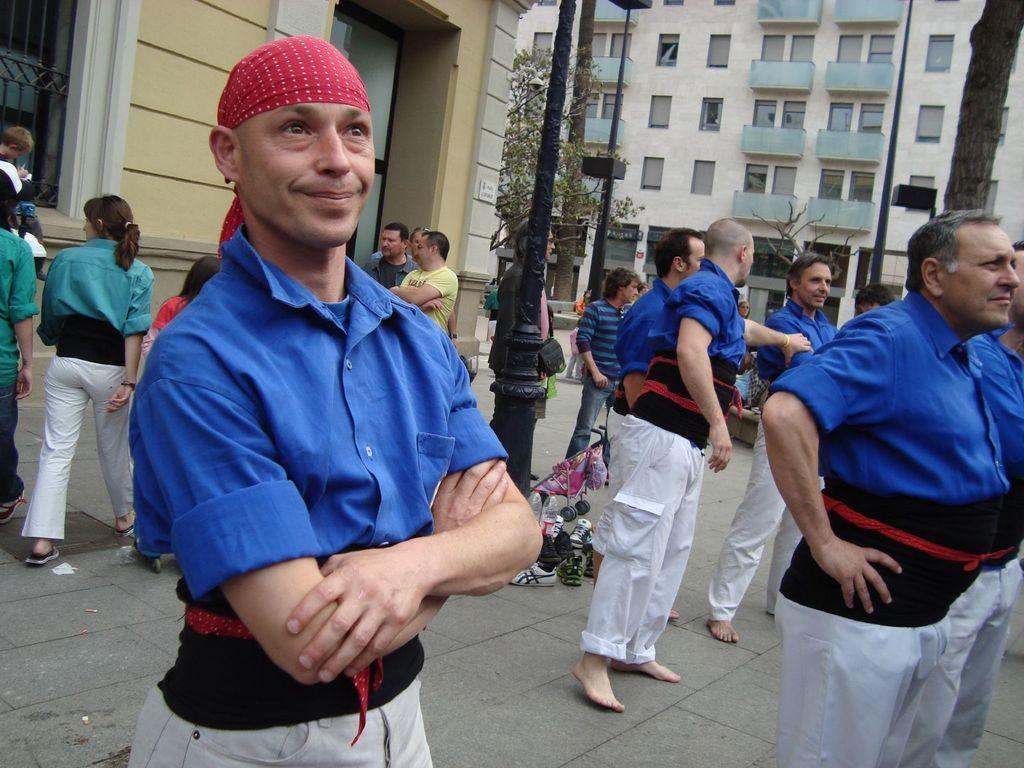What is happening in the image? There is a group of people in the image. Where are the people located? The people are on the ground. What can be seen in the background of the image? There are buildings in the background of the image. What type of shirt is being used to build the nest in the image? There is no shirt or nest present in the image. 